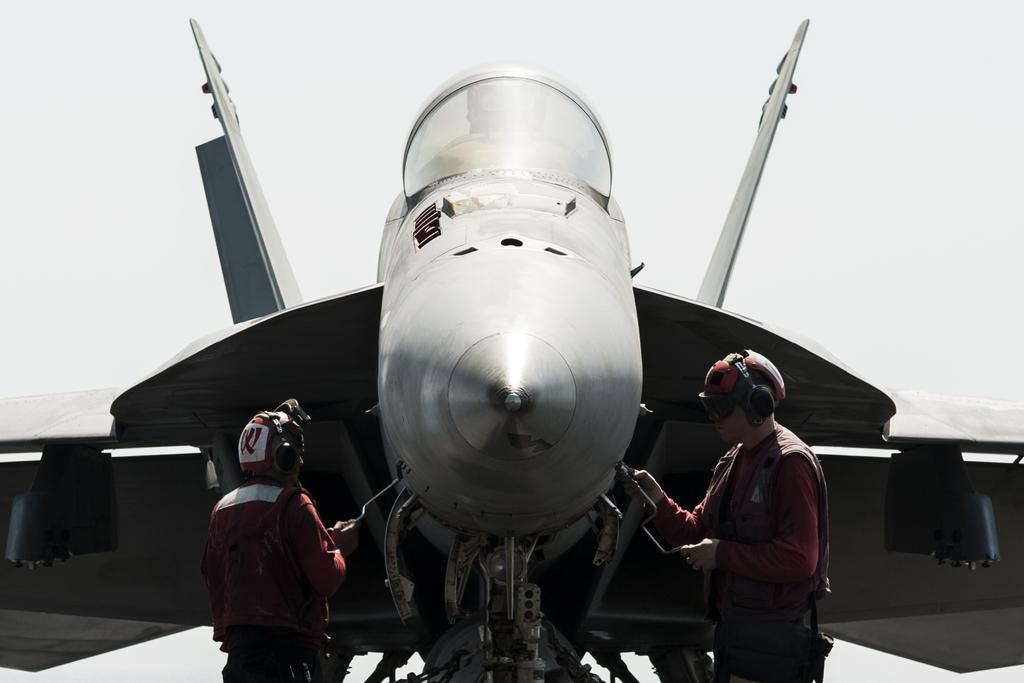How many people are present in the image? There are two persons standing in the image. What are the persons holding in the image? The persons are holding objects. What can be seen in the background of the image? The sky is visible in the background of the image. What is the main subject of the image? The main subject of the image is an aircraft. What type of home can be seen in the image? There is no home present in the image; it features two persons standing with objects and an aircraft. How many trays are visible in the image? There is no tray present in the image. 